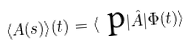Convert formula to latex. <formula><loc_0><loc_0><loc_500><loc_500>\langle A ( s ) \rangle ( t ) = \langle \text { p} | \hat { A } | \Phi ( t ) \rangle</formula> 